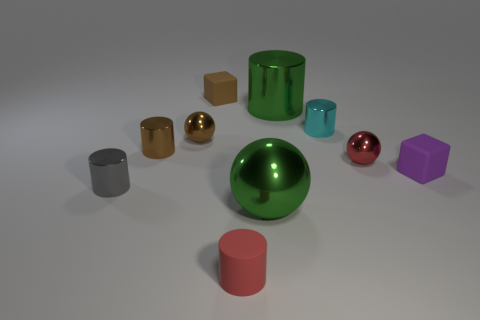Is there anything else that is the same material as the gray object?
Offer a terse response. Yes. What number of other objects are the same color as the big metal cylinder?
Offer a terse response. 1. There is a sphere that is the same color as the big cylinder; what material is it?
Offer a very short reply. Metal. There is a small ball that is on the right side of the small rubber block to the left of the small red thing behind the small gray shiny thing; what is its material?
Provide a succinct answer. Metal. There is a metal thing that is in front of the gray metal thing; is it the same size as the big green shiny cylinder?
Offer a very short reply. Yes. How many small things are either cyan cylinders or rubber cylinders?
Offer a very short reply. 2. Is there a large object that has the same color as the large cylinder?
Provide a short and direct response. Yes. What is the shape of the cyan metal thing that is the same size as the purple block?
Your answer should be very brief. Cylinder. Is the color of the small metal sphere that is to the right of the tiny brown matte block the same as the rubber cylinder?
Ensure brevity in your answer.  Yes. What number of things are metal spheres that are to the left of the rubber cylinder or matte cylinders?
Provide a short and direct response. 2. 